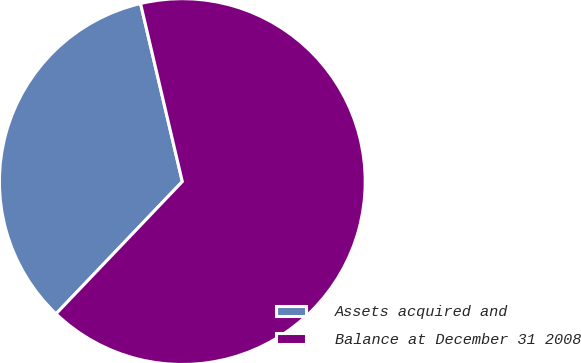Convert chart. <chart><loc_0><loc_0><loc_500><loc_500><pie_chart><fcel>Assets acquired and<fcel>Balance at December 31 2008<nl><fcel>34.2%<fcel>65.8%<nl></chart> 